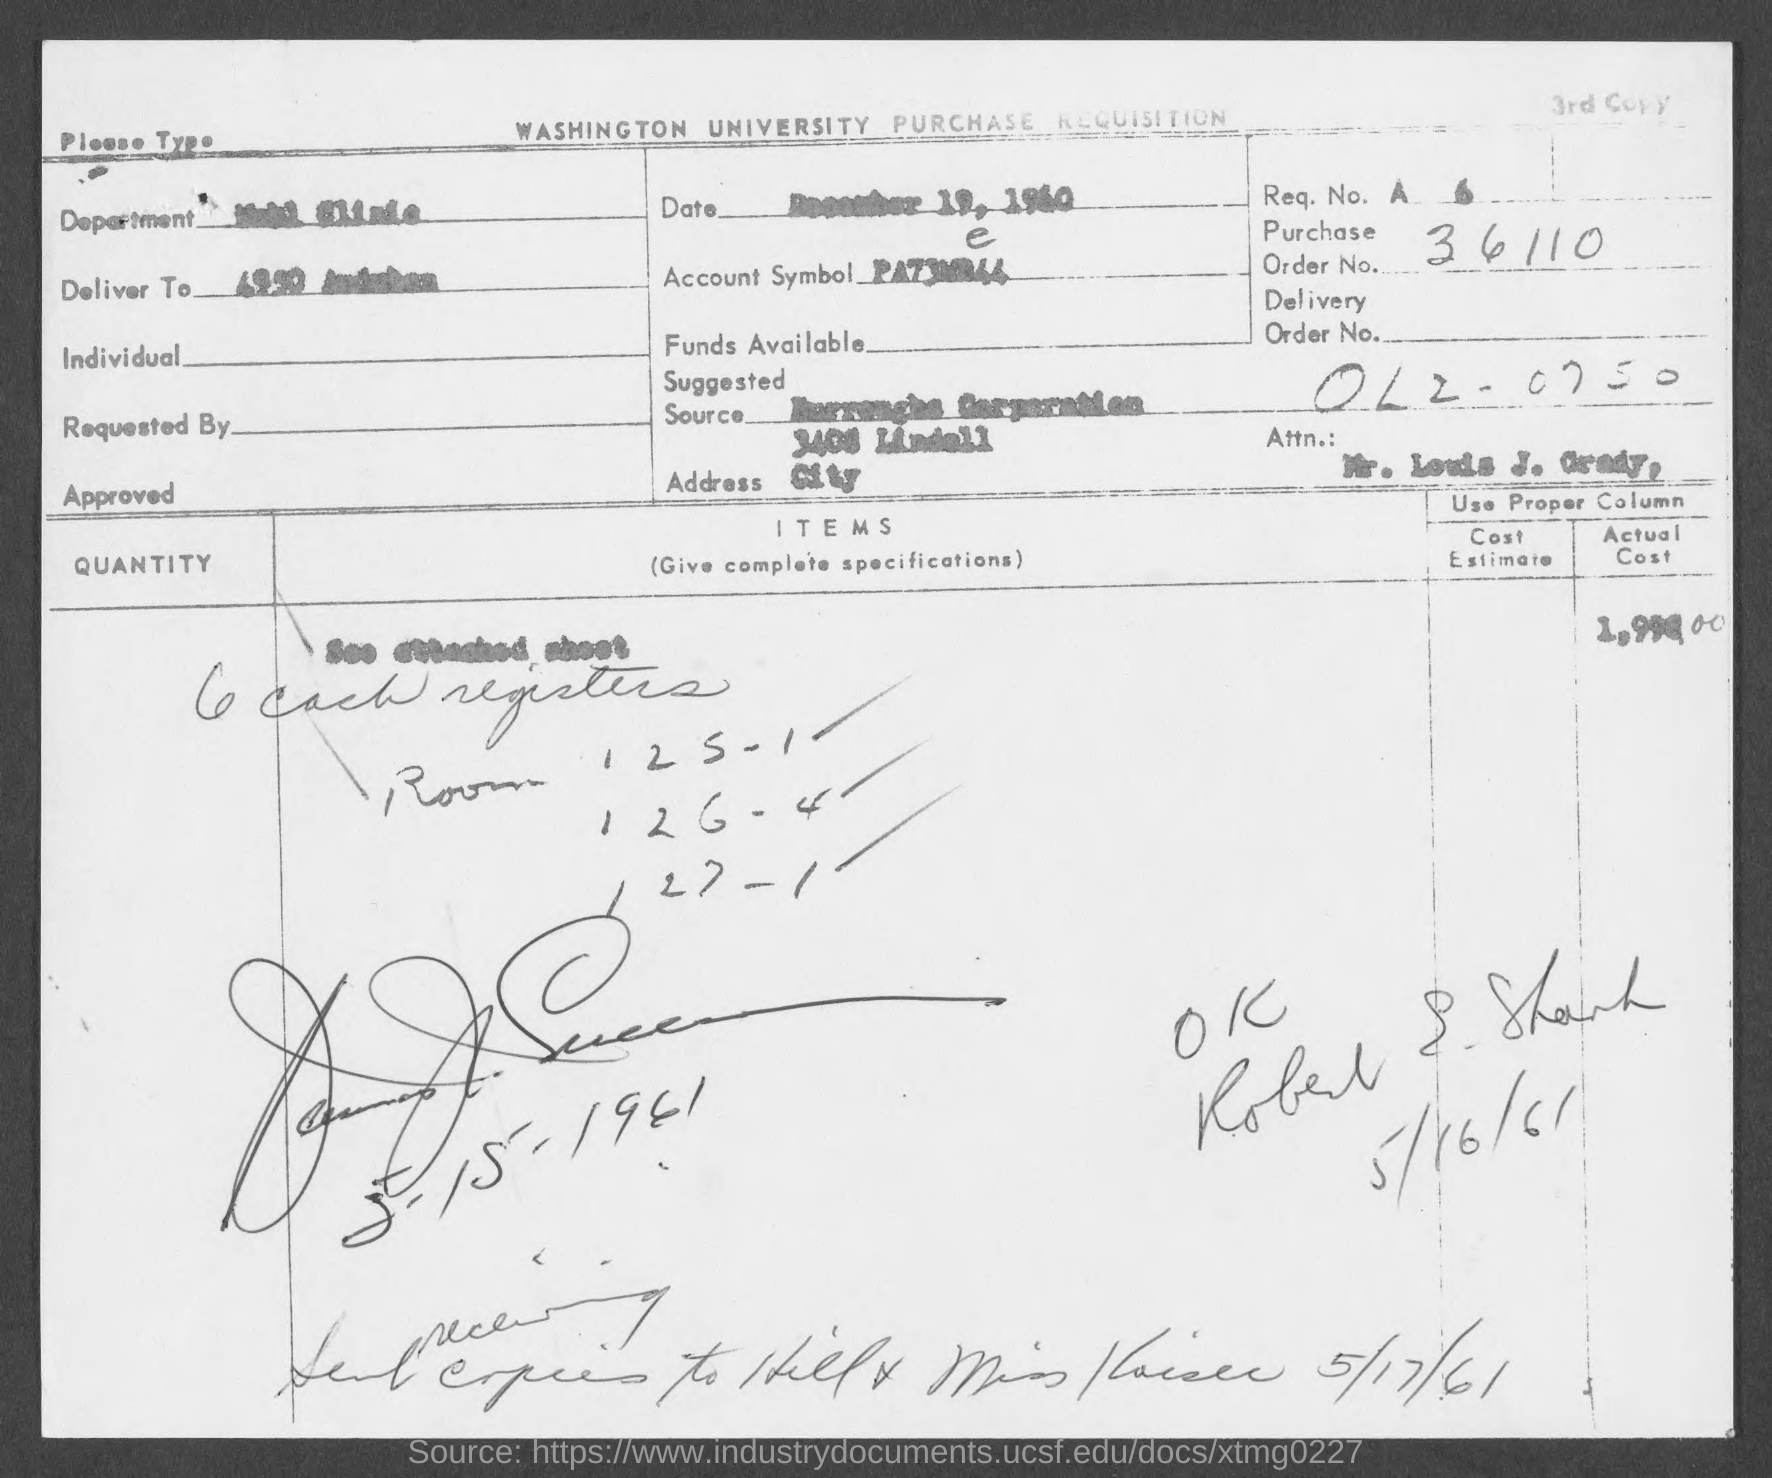Which university's Purchase Requisition is given here?
Give a very brief answer. WASHINGTON UNIVERSITY. What is the Req. No. given in the document?
Your answer should be compact. A  6. What is the Purchase Order No. given in the document?
Provide a short and direct response. 36110. What is the issued date of this document?
Your response must be concise. December 19, 1960. 